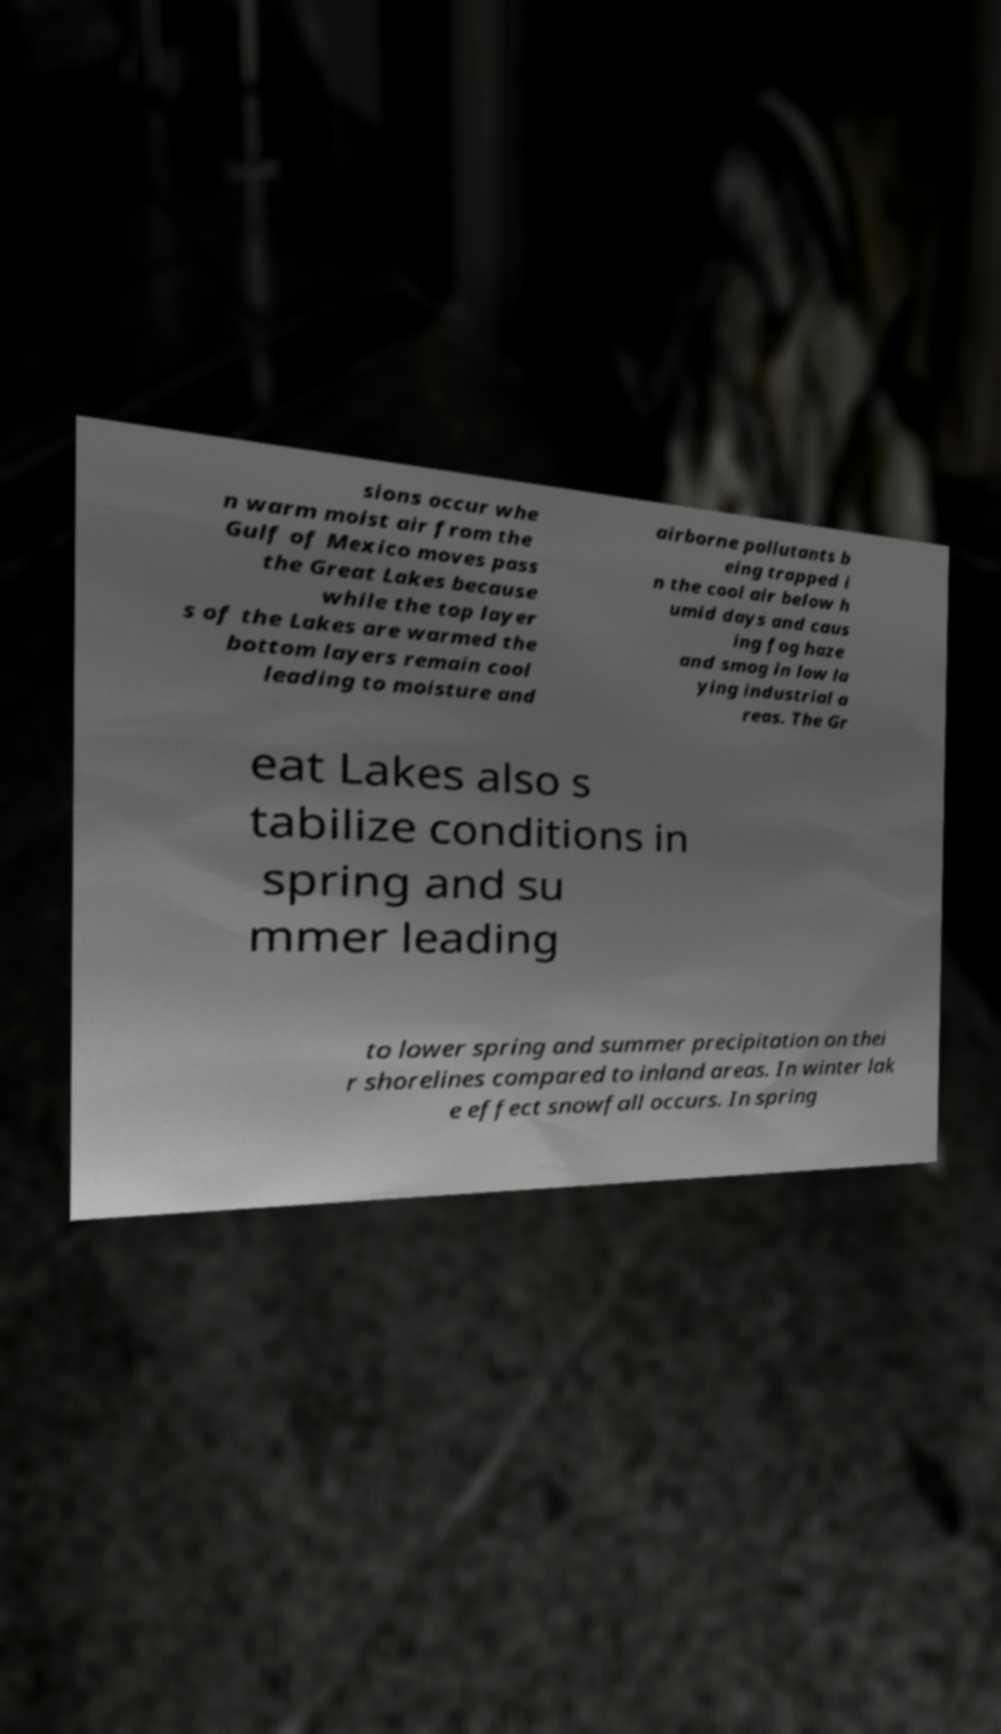Could you extract and type out the text from this image? sions occur whe n warm moist air from the Gulf of Mexico moves pass the Great Lakes because while the top layer s of the Lakes are warmed the bottom layers remain cool leading to moisture and airborne pollutants b eing trapped i n the cool air below h umid days and caus ing fog haze and smog in low la ying industrial a reas. The Gr eat Lakes also s tabilize conditions in spring and su mmer leading to lower spring and summer precipitation on thei r shorelines compared to inland areas. In winter lak e effect snowfall occurs. In spring 